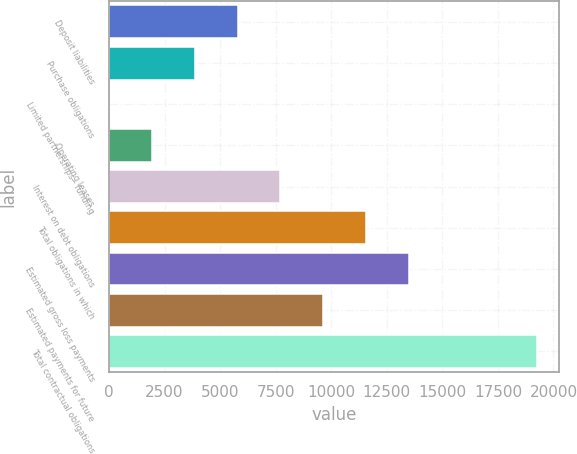Convert chart to OTSL. <chart><loc_0><loc_0><loc_500><loc_500><bar_chart><fcel>Deposit liabilities<fcel>Purchase obligations<fcel>Limited partnerships - funding<fcel>Operating leases<fcel>Interest on debt obligations<fcel>Total obligations in which<fcel>Estimated gross loss payments<fcel>Estimated payments for future<fcel>Total contractual obligations<nl><fcel>5787.9<fcel>3862.6<fcel>12<fcel>1937.3<fcel>7713.2<fcel>11563.8<fcel>13489.1<fcel>9638.5<fcel>19265<nl></chart> 